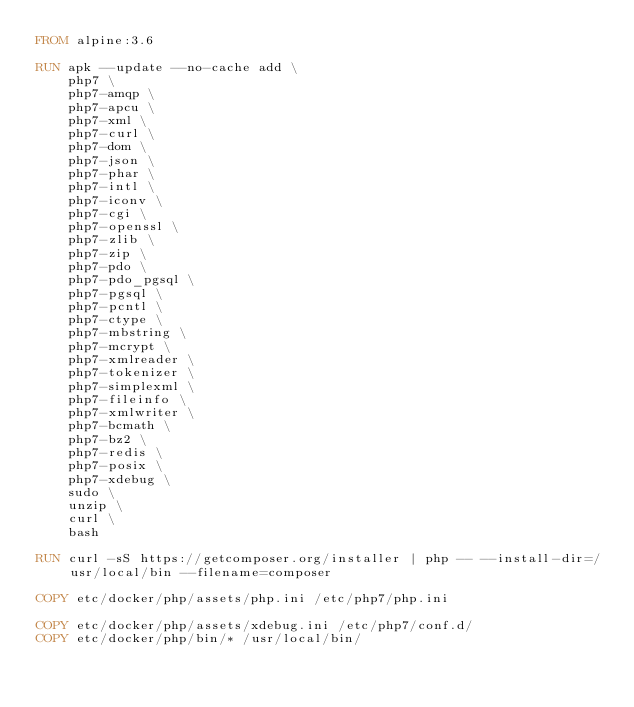<code> <loc_0><loc_0><loc_500><loc_500><_Dockerfile_>FROM alpine:3.6

RUN apk --update --no-cache add \
    php7 \
    php7-amqp \
    php7-apcu \
    php7-xml \
    php7-curl \
    php7-dom \
    php7-json \
    php7-phar \
    php7-intl \
    php7-iconv \
    php7-cgi \
    php7-openssl \
    php7-zlib \
    php7-zip \
    php7-pdo \
    php7-pdo_pgsql \
    php7-pgsql \
    php7-pcntl \
    php7-ctype \
    php7-mbstring \
    php7-mcrypt \
    php7-xmlreader \
    php7-tokenizer \
    php7-simplexml \
    php7-fileinfo \
    php7-xmlwriter \
    php7-bcmath \
    php7-bz2 \
    php7-redis \
    php7-posix \
    php7-xdebug \
    sudo \
    unzip \
    curl \
    bash

RUN curl -sS https://getcomposer.org/installer | php -- --install-dir=/usr/local/bin --filename=composer

COPY etc/docker/php/assets/php.ini /etc/php7/php.ini

COPY etc/docker/php/assets/xdebug.ini /etc/php7/conf.d/
COPY etc/docker/php/bin/* /usr/local/bin/
</code> 